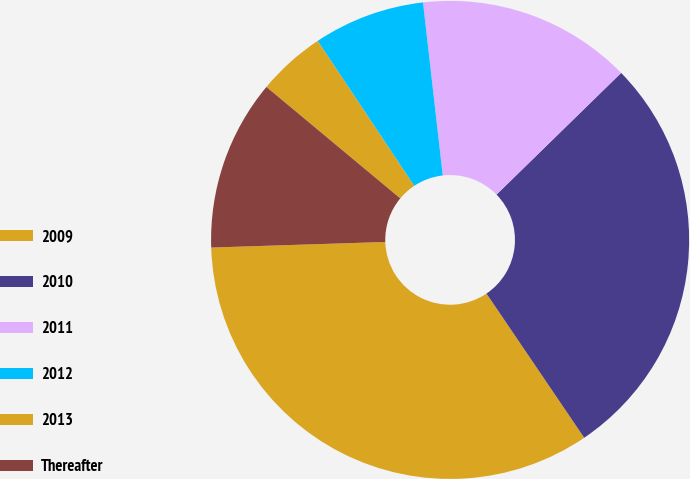Convert chart. <chart><loc_0><loc_0><loc_500><loc_500><pie_chart><fcel>2009<fcel>2010<fcel>2011<fcel>2012<fcel>2013<fcel>Thereafter<nl><fcel>33.97%<fcel>27.83%<fcel>14.5%<fcel>7.54%<fcel>4.6%<fcel>11.56%<nl></chart> 